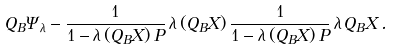<formula> <loc_0><loc_0><loc_500><loc_500>Q _ { B } \Psi _ { \lambda } - \frac { 1 } { 1 - \lambda \, ( Q _ { B } X ) \, P } \, \lambda \, ( Q _ { B } X ) \, \frac { 1 } { 1 - \lambda \, ( Q _ { B } X ) \, P } \, \lambda \, Q _ { B } X \, .</formula> 